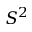Convert formula to latex. <formula><loc_0><loc_0><loc_500><loc_500>S ^ { 2 }</formula> 